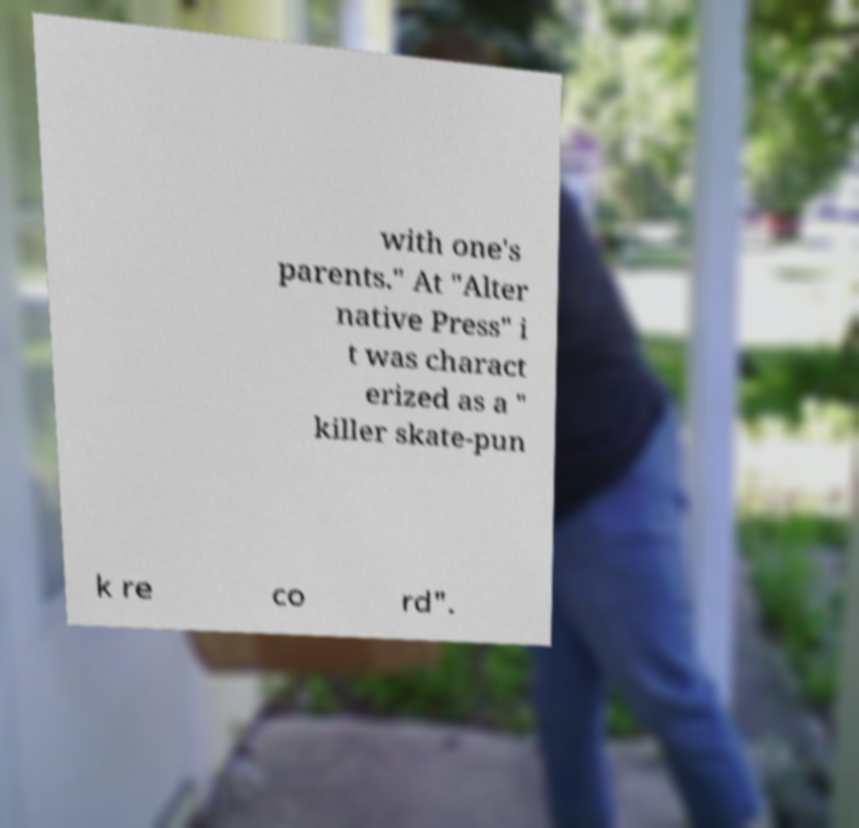Can you read and provide the text displayed in the image?This photo seems to have some interesting text. Can you extract and type it out for me? with one's parents." At "Alter native Press" i t was charact erized as a " killer skate-pun k re co rd". 